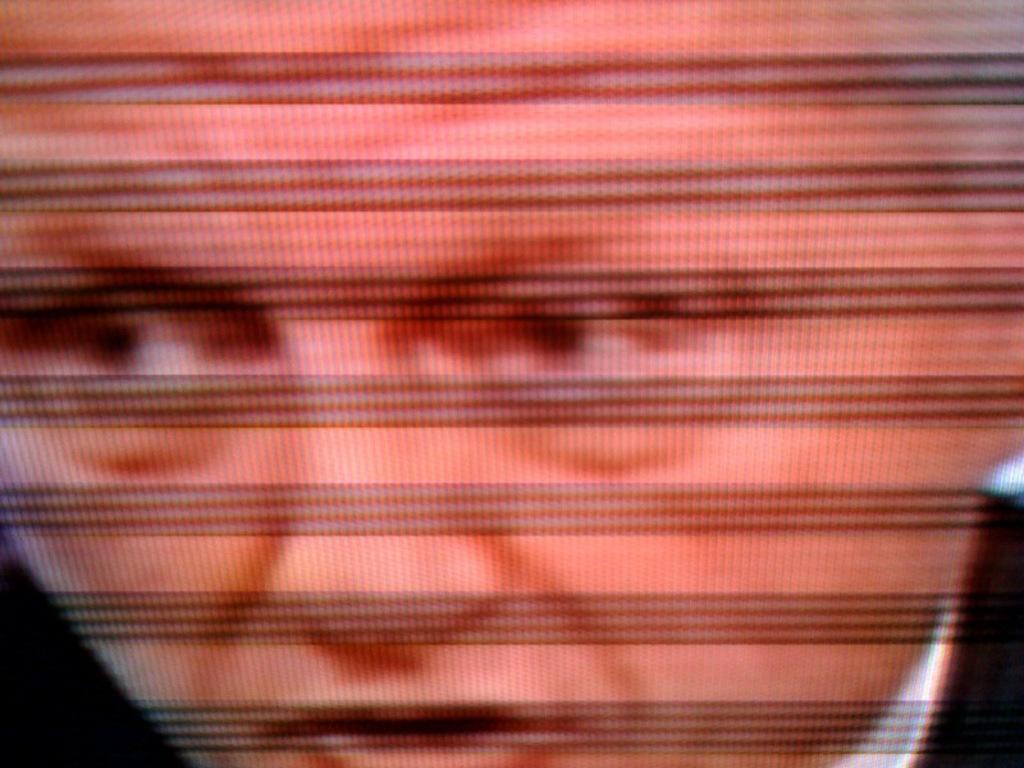Describe this image in one or two sentences. In this image we can see a person on the screen. 